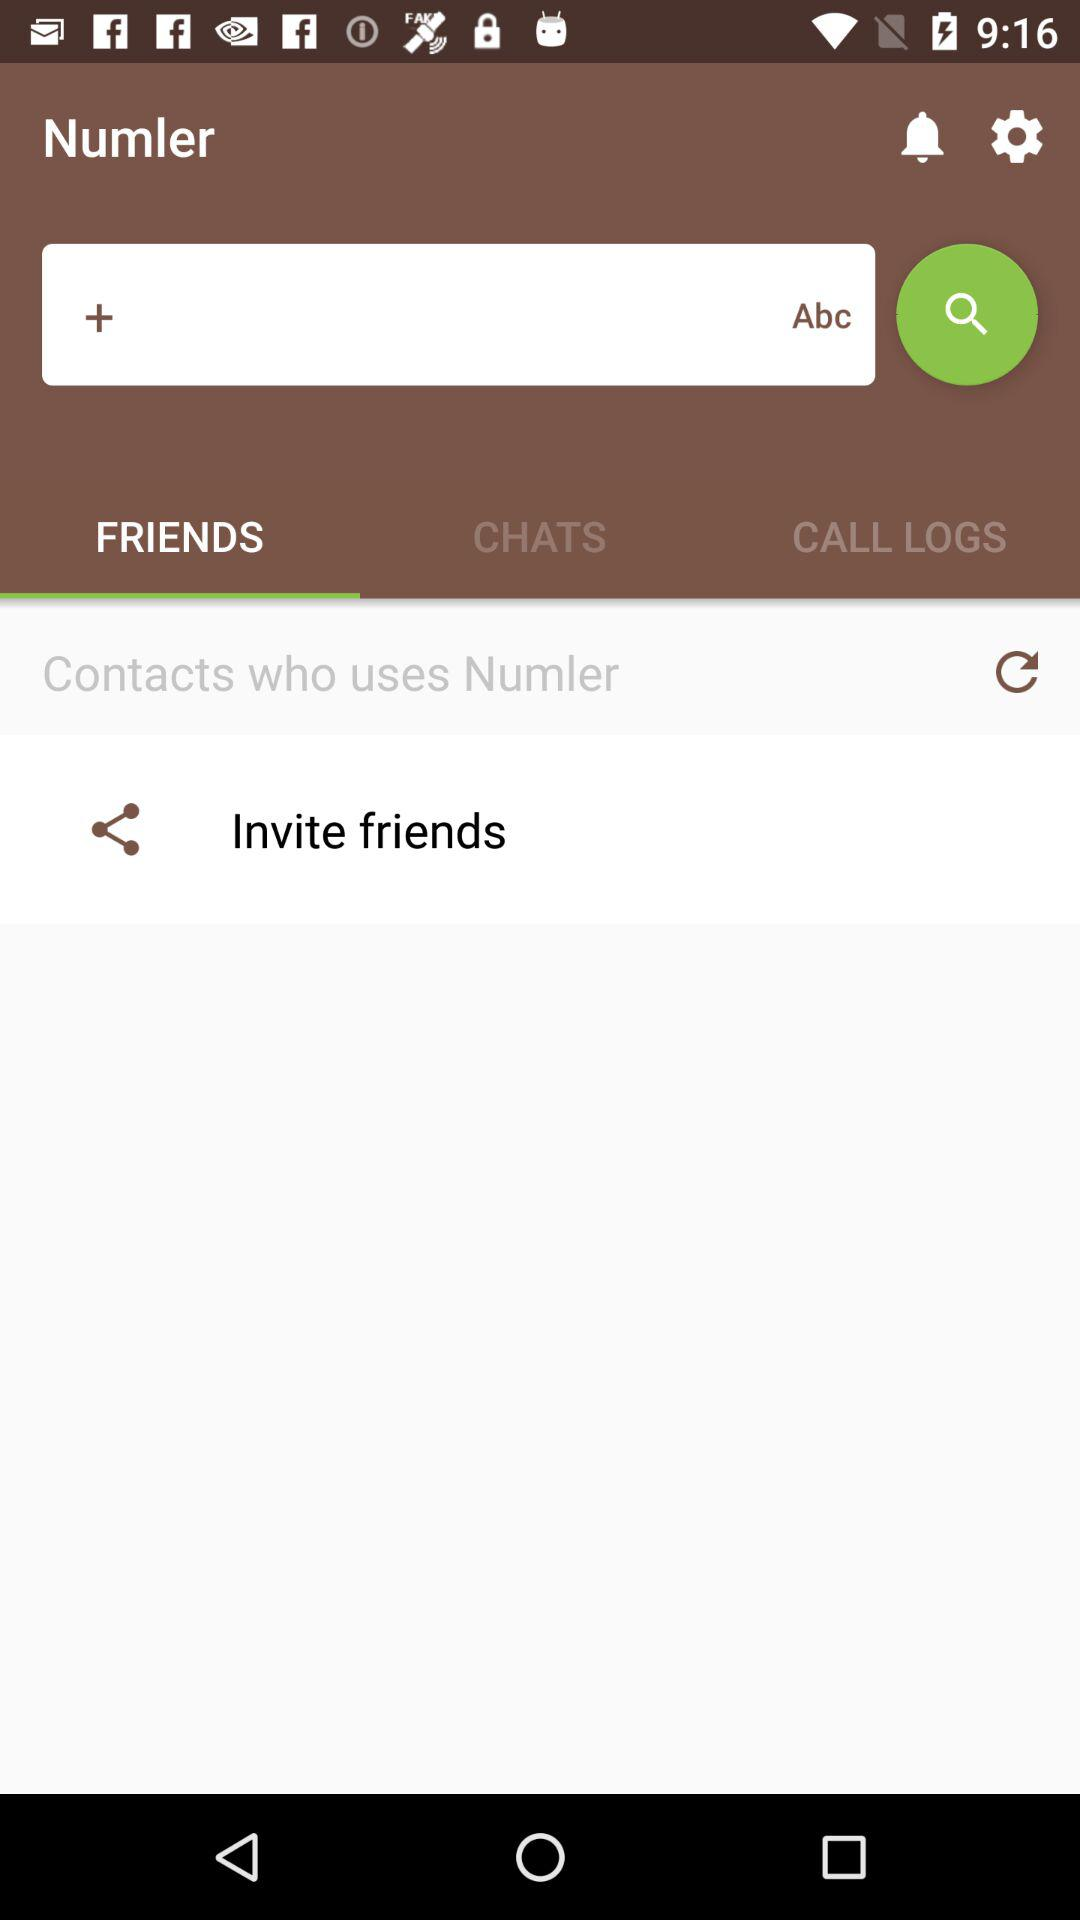Who is listed in "CHATS"?
When the provided information is insufficient, respond with <no answer>. <no answer> 